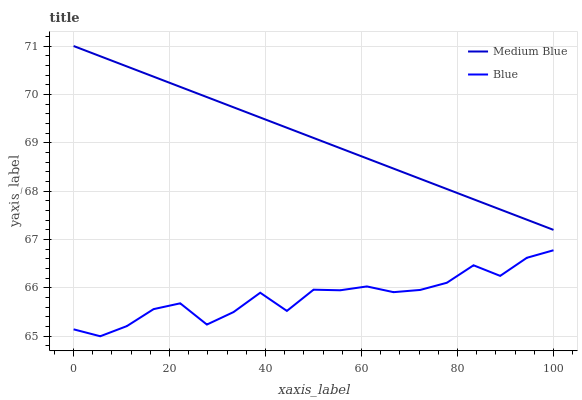Does Blue have the minimum area under the curve?
Answer yes or no. Yes. Does Medium Blue have the maximum area under the curve?
Answer yes or no. Yes. Does Medium Blue have the minimum area under the curve?
Answer yes or no. No. Is Medium Blue the smoothest?
Answer yes or no. Yes. Is Blue the roughest?
Answer yes or no. Yes. Is Medium Blue the roughest?
Answer yes or no. No. Does Blue have the lowest value?
Answer yes or no. Yes. Does Medium Blue have the lowest value?
Answer yes or no. No. Does Medium Blue have the highest value?
Answer yes or no. Yes. Is Blue less than Medium Blue?
Answer yes or no. Yes. Is Medium Blue greater than Blue?
Answer yes or no. Yes. Does Blue intersect Medium Blue?
Answer yes or no. No. 